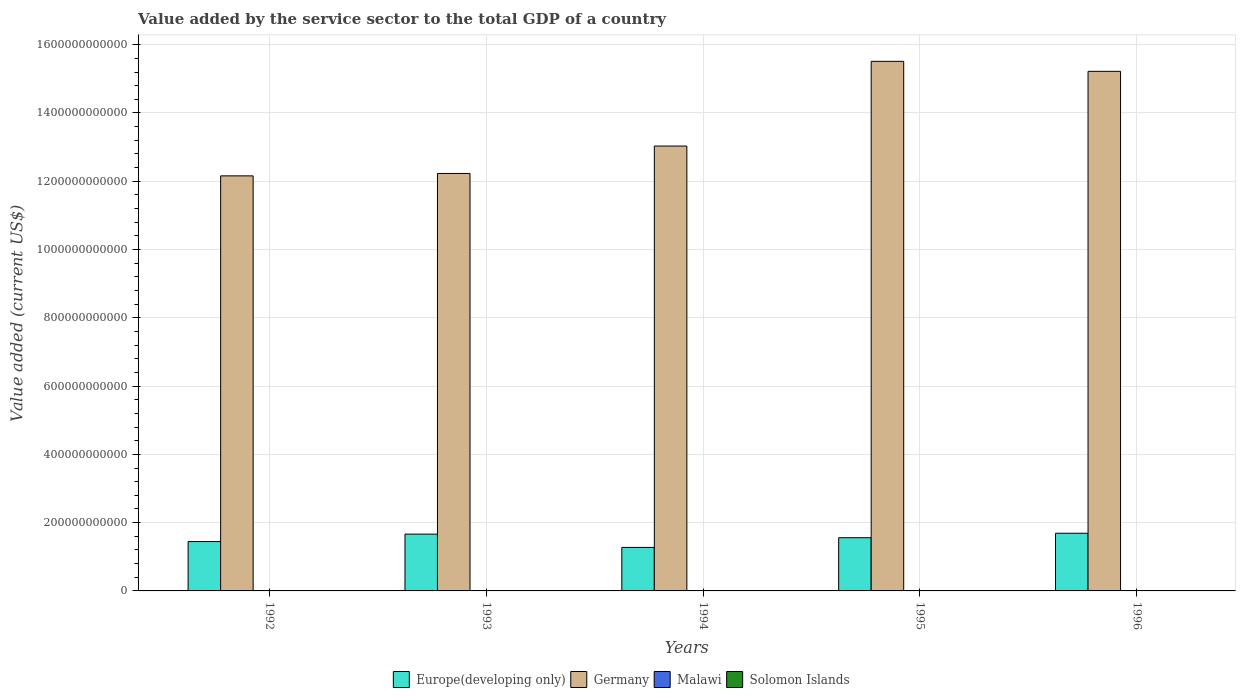How many different coloured bars are there?
Make the answer very short. 4. How many groups of bars are there?
Provide a short and direct response. 5. How many bars are there on the 4th tick from the left?
Provide a short and direct response. 4. What is the value added by the service sector to the total GDP in Germany in 1995?
Keep it short and to the point. 1.55e+12. Across all years, what is the maximum value added by the service sector to the total GDP in Malawi?
Your answer should be very brief. 9.50e+08. Across all years, what is the minimum value added by the service sector to the total GDP in Germany?
Offer a very short reply. 1.22e+12. What is the total value added by the service sector to the total GDP in Germany in the graph?
Your answer should be very brief. 6.81e+12. What is the difference between the value added by the service sector to the total GDP in Malawi in 1992 and that in 1995?
Give a very brief answer. -1.37e+08. What is the difference between the value added by the service sector to the total GDP in Germany in 1992 and the value added by the service sector to the total GDP in Malawi in 1994?
Offer a very short reply. 1.22e+12. What is the average value added by the service sector to the total GDP in Europe(developing only) per year?
Provide a succinct answer. 1.53e+11. In the year 1995, what is the difference between the value added by the service sector to the total GDP in Solomon Islands and value added by the service sector to the total GDP in Malawi?
Offer a very short reply. -4.15e+08. What is the ratio of the value added by the service sector to the total GDP in Germany in 1992 to that in 1995?
Your answer should be compact. 0.78. Is the value added by the service sector to the total GDP in Europe(developing only) in 1992 less than that in 1993?
Make the answer very short. Yes. What is the difference between the highest and the second highest value added by the service sector to the total GDP in Malawi?
Make the answer very short. 3.33e+08. What is the difference between the highest and the lowest value added by the service sector to the total GDP in Solomon Islands?
Ensure brevity in your answer.  9.79e+07. Is the sum of the value added by the service sector to the total GDP in Malawi in 1994 and 1996 greater than the maximum value added by the service sector to the total GDP in Solomon Islands across all years?
Your answer should be compact. Yes. Is it the case that in every year, the sum of the value added by the service sector to the total GDP in Solomon Islands and value added by the service sector to the total GDP in Malawi is greater than the sum of value added by the service sector to the total GDP in Germany and value added by the service sector to the total GDP in Europe(developing only)?
Make the answer very short. No. What does the 2nd bar from the left in 1996 represents?
Offer a very short reply. Germany. What does the 2nd bar from the right in 1996 represents?
Provide a short and direct response. Malawi. Is it the case that in every year, the sum of the value added by the service sector to the total GDP in Solomon Islands and value added by the service sector to the total GDP in Germany is greater than the value added by the service sector to the total GDP in Europe(developing only)?
Give a very brief answer. Yes. Are all the bars in the graph horizontal?
Your answer should be very brief. No. What is the difference between two consecutive major ticks on the Y-axis?
Keep it short and to the point. 2.00e+11. Does the graph contain grids?
Give a very brief answer. Yes. Where does the legend appear in the graph?
Your answer should be very brief. Bottom center. How are the legend labels stacked?
Make the answer very short. Horizontal. What is the title of the graph?
Give a very brief answer. Value added by the service sector to the total GDP of a country. What is the label or title of the X-axis?
Make the answer very short. Years. What is the label or title of the Y-axis?
Your answer should be compact. Value added (current US$). What is the Value added (current US$) of Europe(developing only) in 1992?
Provide a short and direct response. 1.45e+11. What is the Value added (current US$) of Germany in 1992?
Make the answer very short. 1.22e+12. What is the Value added (current US$) of Malawi in 1992?
Offer a very short reply. 4.80e+08. What is the Value added (current US$) in Solomon Islands in 1992?
Ensure brevity in your answer.  1.33e+08. What is the Value added (current US$) in Europe(developing only) in 1993?
Offer a very short reply. 1.66e+11. What is the Value added (current US$) of Germany in 1993?
Offer a terse response. 1.22e+12. What is the Value added (current US$) of Malawi in 1993?
Your response must be concise. 5.12e+08. What is the Value added (current US$) in Solomon Islands in 1993?
Keep it short and to the point. 1.49e+08. What is the Value added (current US$) in Europe(developing only) in 1994?
Ensure brevity in your answer.  1.27e+11. What is the Value added (current US$) of Germany in 1994?
Make the answer very short. 1.30e+12. What is the Value added (current US$) of Malawi in 1994?
Make the answer very short. 5.60e+08. What is the Value added (current US$) of Solomon Islands in 1994?
Give a very brief answer. 1.65e+08. What is the Value added (current US$) of Europe(developing only) in 1995?
Give a very brief answer. 1.56e+11. What is the Value added (current US$) of Germany in 1995?
Make the answer very short. 1.55e+12. What is the Value added (current US$) of Malawi in 1995?
Offer a very short reply. 6.17e+08. What is the Value added (current US$) of Solomon Islands in 1995?
Give a very brief answer. 2.01e+08. What is the Value added (current US$) in Europe(developing only) in 1996?
Offer a terse response. 1.69e+11. What is the Value added (current US$) in Germany in 1996?
Provide a succinct answer. 1.52e+12. What is the Value added (current US$) of Malawi in 1996?
Provide a succinct answer. 9.50e+08. What is the Value added (current US$) of Solomon Islands in 1996?
Your answer should be compact. 2.31e+08. Across all years, what is the maximum Value added (current US$) in Europe(developing only)?
Ensure brevity in your answer.  1.69e+11. Across all years, what is the maximum Value added (current US$) of Germany?
Your answer should be very brief. 1.55e+12. Across all years, what is the maximum Value added (current US$) of Malawi?
Give a very brief answer. 9.50e+08. Across all years, what is the maximum Value added (current US$) of Solomon Islands?
Your answer should be very brief. 2.31e+08. Across all years, what is the minimum Value added (current US$) in Europe(developing only)?
Provide a short and direct response. 1.27e+11. Across all years, what is the minimum Value added (current US$) in Germany?
Your answer should be compact. 1.22e+12. Across all years, what is the minimum Value added (current US$) of Malawi?
Offer a terse response. 4.80e+08. Across all years, what is the minimum Value added (current US$) of Solomon Islands?
Ensure brevity in your answer.  1.33e+08. What is the total Value added (current US$) of Europe(developing only) in the graph?
Offer a terse response. 7.63e+11. What is the total Value added (current US$) of Germany in the graph?
Your answer should be very brief. 6.81e+12. What is the total Value added (current US$) in Malawi in the graph?
Your answer should be very brief. 3.12e+09. What is the total Value added (current US$) in Solomon Islands in the graph?
Provide a succinct answer. 8.80e+08. What is the difference between the Value added (current US$) of Europe(developing only) in 1992 and that in 1993?
Your answer should be compact. -2.18e+1. What is the difference between the Value added (current US$) of Germany in 1992 and that in 1993?
Offer a terse response. -7.06e+09. What is the difference between the Value added (current US$) of Malawi in 1992 and that in 1993?
Make the answer very short. -3.14e+07. What is the difference between the Value added (current US$) of Solomon Islands in 1992 and that in 1993?
Keep it short and to the point. -1.59e+07. What is the difference between the Value added (current US$) of Europe(developing only) in 1992 and that in 1994?
Offer a terse response. 1.72e+1. What is the difference between the Value added (current US$) of Germany in 1992 and that in 1994?
Make the answer very short. -8.74e+1. What is the difference between the Value added (current US$) in Malawi in 1992 and that in 1994?
Provide a short and direct response. -8.02e+07. What is the difference between the Value added (current US$) of Solomon Islands in 1992 and that in 1994?
Make the answer very short. -3.12e+07. What is the difference between the Value added (current US$) in Europe(developing only) in 1992 and that in 1995?
Offer a very short reply. -1.13e+1. What is the difference between the Value added (current US$) of Germany in 1992 and that in 1995?
Make the answer very short. -3.35e+11. What is the difference between the Value added (current US$) in Malawi in 1992 and that in 1995?
Offer a very short reply. -1.37e+08. What is the difference between the Value added (current US$) in Solomon Islands in 1992 and that in 1995?
Your answer should be compact. -6.80e+07. What is the difference between the Value added (current US$) in Europe(developing only) in 1992 and that in 1996?
Your answer should be very brief. -2.44e+1. What is the difference between the Value added (current US$) of Germany in 1992 and that in 1996?
Ensure brevity in your answer.  -3.06e+11. What is the difference between the Value added (current US$) of Malawi in 1992 and that in 1996?
Provide a succinct answer. -4.69e+08. What is the difference between the Value added (current US$) of Solomon Islands in 1992 and that in 1996?
Make the answer very short. -9.79e+07. What is the difference between the Value added (current US$) of Europe(developing only) in 1993 and that in 1994?
Give a very brief answer. 3.90e+1. What is the difference between the Value added (current US$) in Germany in 1993 and that in 1994?
Offer a terse response. -8.03e+1. What is the difference between the Value added (current US$) of Malawi in 1993 and that in 1994?
Your answer should be compact. -4.88e+07. What is the difference between the Value added (current US$) in Solomon Islands in 1993 and that in 1994?
Give a very brief answer. -1.53e+07. What is the difference between the Value added (current US$) of Europe(developing only) in 1993 and that in 1995?
Provide a short and direct response. 1.05e+1. What is the difference between the Value added (current US$) of Germany in 1993 and that in 1995?
Make the answer very short. -3.28e+11. What is the difference between the Value added (current US$) in Malawi in 1993 and that in 1995?
Your answer should be compact. -1.05e+08. What is the difference between the Value added (current US$) of Solomon Islands in 1993 and that in 1995?
Make the answer very short. -5.21e+07. What is the difference between the Value added (current US$) of Europe(developing only) in 1993 and that in 1996?
Ensure brevity in your answer.  -2.57e+09. What is the difference between the Value added (current US$) in Germany in 1993 and that in 1996?
Provide a succinct answer. -2.99e+11. What is the difference between the Value added (current US$) of Malawi in 1993 and that in 1996?
Make the answer very short. -4.38e+08. What is the difference between the Value added (current US$) of Solomon Islands in 1993 and that in 1996?
Your response must be concise. -8.20e+07. What is the difference between the Value added (current US$) in Europe(developing only) in 1994 and that in 1995?
Give a very brief answer. -2.84e+1. What is the difference between the Value added (current US$) of Germany in 1994 and that in 1995?
Provide a succinct answer. -2.48e+11. What is the difference between the Value added (current US$) of Malawi in 1994 and that in 1995?
Your answer should be very brief. -5.64e+07. What is the difference between the Value added (current US$) of Solomon Islands in 1994 and that in 1995?
Your response must be concise. -3.68e+07. What is the difference between the Value added (current US$) in Europe(developing only) in 1994 and that in 1996?
Offer a very short reply. -4.15e+1. What is the difference between the Value added (current US$) of Germany in 1994 and that in 1996?
Make the answer very short. -2.19e+11. What is the difference between the Value added (current US$) in Malawi in 1994 and that in 1996?
Ensure brevity in your answer.  -3.89e+08. What is the difference between the Value added (current US$) in Solomon Islands in 1994 and that in 1996?
Make the answer very short. -6.67e+07. What is the difference between the Value added (current US$) in Europe(developing only) in 1995 and that in 1996?
Offer a very short reply. -1.31e+1. What is the difference between the Value added (current US$) in Germany in 1995 and that in 1996?
Give a very brief answer. 2.92e+1. What is the difference between the Value added (current US$) in Malawi in 1995 and that in 1996?
Your answer should be very brief. -3.33e+08. What is the difference between the Value added (current US$) in Solomon Islands in 1995 and that in 1996?
Provide a succinct answer. -2.99e+07. What is the difference between the Value added (current US$) of Europe(developing only) in 1992 and the Value added (current US$) of Germany in 1993?
Your answer should be very brief. -1.08e+12. What is the difference between the Value added (current US$) of Europe(developing only) in 1992 and the Value added (current US$) of Malawi in 1993?
Make the answer very short. 1.44e+11. What is the difference between the Value added (current US$) of Europe(developing only) in 1992 and the Value added (current US$) of Solomon Islands in 1993?
Offer a terse response. 1.44e+11. What is the difference between the Value added (current US$) of Germany in 1992 and the Value added (current US$) of Malawi in 1993?
Give a very brief answer. 1.22e+12. What is the difference between the Value added (current US$) in Germany in 1992 and the Value added (current US$) in Solomon Islands in 1993?
Give a very brief answer. 1.22e+12. What is the difference between the Value added (current US$) in Malawi in 1992 and the Value added (current US$) in Solomon Islands in 1993?
Your response must be concise. 3.31e+08. What is the difference between the Value added (current US$) in Europe(developing only) in 1992 and the Value added (current US$) in Germany in 1994?
Your response must be concise. -1.16e+12. What is the difference between the Value added (current US$) of Europe(developing only) in 1992 and the Value added (current US$) of Malawi in 1994?
Offer a terse response. 1.44e+11. What is the difference between the Value added (current US$) of Europe(developing only) in 1992 and the Value added (current US$) of Solomon Islands in 1994?
Keep it short and to the point. 1.44e+11. What is the difference between the Value added (current US$) of Germany in 1992 and the Value added (current US$) of Malawi in 1994?
Provide a succinct answer. 1.22e+12. What is the difference between the Value added (current US$) of Germany in 1992 and the Value added (current US$) of Solomon Islands in 1994?
Your answer should be very brief. 1.22e+12. What is the difference between the Value added (current US$) of Malawi in 1992 and the Value added (current US$) of Solomon Islands in 1994?
Offer a very short reply. 3.16e+08. What is the difference between the Value added (current US$) in Europe(developing only) in 1992 and the Value added (current US$) in Germany in 1995?
Your answer should be very brief. -1.41e+12. What is the difference between the Value added (current US$) of Europe(developing only) in 1992 and the Value added (current US$) of Malawi in 1995?
Give a very brief answer. 1.44e+11. What is the difference between the Value added (current US$) in Europe(developing only) in 1992 and the Value added (current US$) in Solomon Islands in 1995?
Keep it short and to the point. 1.44e+11. What is the difference between the Value added (current US$) in Germany in 1992 and the Value added (current US$) in Malawi in 1995?
Your answer should be very brief. 1.22e+12. What is the difference between the Value added (current US$) in Germany in 1992 and the Value added (current US$) in Solomon Islands in 1995?
Your response must be concise. 1.22e+12. What is the difference between the Value added (current US$) of Malawi in 1992 and the Value added (current US$) of Solomon Islands in 1995?
Offer a terse response. 2.79e+08. What is the difference between the Value added (current US$) of Europe(developing only) in 1992 and the Value added (current US$) of Germany in 1996?
Offer a terse response. -1.38e+12. What is the difference between the Value added (current US$) of Europe(developing only) in 1992 and the Value added (current US$) of Malawi in 1996?
Your answer should be compact. 1.44e+11. What is the difference between the Value added (current US$) in Europe(developing only) in 1992 and the Value added (current US$) in Solomon Islands in 1996?
Your response must be concise. 1.44e+11. What is the difference between the Value added (current US$) in Germany in 1992 and the Value added (current US$) in Malawi in 1996?
Offer a very short reply. 1.21e+12. What is the difference between the Value added (current US$) of Germany in 1992 and the Value added (current US$) of Solomon Islands in 1996?
Provide a succinct answer. 1.22e+12. What is the difference between the Value added (current US$) of Malawi in 1992 and the Value added (current US$) of Solomon Islands in 1996?
Ensure brevity in your answer.  2.49e+08. What is the difference between the Value added (current US$) of Europe(developing only) in 1993 and the Value added (current US$) of Germany in 1994?
Your answer should be compact. -1.14e+12. What is the difference between the Value added (current US$) of Europe(developing only) in 1993 and the Value added (current US$) of Malawi in 1994?
Your response must be concise. 1.66e+11. What is the difference between the Value added (current US$) in Europe(developing only) in 1993 and the Value added (current US$) in Solomon Islands in 1994?
Keep it short and to the point. 1.66e+11. What is the difference between the Value added (current US$) in Germany in 1993 and the Value added (current US$) in Malawi in 1994?
Provide a succinct answer. 1.22e+12. What is the difference between the Value added (current US$) of Germany in 1993 and the Value added (current US$) of Solomon Islands in 1994?
Make the answer very short. 1.22e+12. What is the difference between the Value added (current US$) of Malawi in 1993 and the Value added (current US$) of Solomon Islands in 1994?
Provide a succinct answer. 3.47e+08. What is the difference between the Value added (current US$) in Europe(developing only) in 1993 and the Value added (current US$) in Germany in 1995?
Give a very brief answer. -1.38e+12. What is the difference between the Value added (current US$) in Europe(developing only) in 1993 and the Value added (current US$) in Malawi in 1995?
Provide a short and direct response. 1.66e+11. What is the difference between the Value added (current US$) of Europe(developing only) in 1993 and the Value added (current US$) of Solomon Islands in 1995?
Offer a terse response. 1.66e+11. What is the difference between the Value added (current US$) in Germany in 1993 and the Value added (current US$) in Malawi in 1995?
Your response must be concise. 1.22e+12. What is the difference between the Value added (current US$) in Germany in 1993 and the Value added (current US$) in Solomon Islands in 1995?
Provide a succinct answer. 1.22e+12. What is the difference between the Value added (current US$) in Malawi in 1993 and the Value added (current US$) in Solomon Islands in 1995?
Ensure brevity in your answer.  3.10e+08. What is the difference between the Value added (current US$) of Europe(developing only) in 1993 and the Value added (current US$) of Germany in 1996?
Ensure brevity in your answer.  -1.36e+12. What is the difference between the Value added (current US$) of Europe(developing only) in 1993 and the Value added (current US$) of Malawi in 1996?
Provide a short and direct response. 1.65e+11. What is the difference between the Value added (current US$) in Europe(developing only) in 1993 and the Value added (current US$) in Solomon Islands in 1996?
Offer a very short reply. 1.66e+11. What is the difference between the Value added (current US$) of Germany in 1993 and the Value added (current US$) of Malawi in 1996?
Ensure brevity in your answer.  1.22e+12. What is the difference between the Value added (current US$) in Germany in 1993 and the Value added (current US$) in Solomon Islands in 1996?
Provide a succinct answer. 1.22e+12. What is the difference between the Value added (current US$) of Malawi in 1993 and the Value added (current US$) of Solomon Islands in 1996?
Provide a short and direct response. 2.80e+08. What is the difference between the Value added (current US$) in Europe(developing only) in 1994 and the Value added (current US$) in Germany in 1995?
Keep it short and to the point. -1.42e+12. What is the difference between the Value added (current US$) in Europe(developing only) in 1994 and the Value added (current US$) in Malawi in 1995?
Your response must be concise. 1.27e+11. What is the difference between the Value added (current US$) in Europe(developing only) in 1994 and the Value added (current US$) in Solomon Islands in 1995?
Provide a short and direct response. 1.27e+11. What is the difference between the Value added (current US$) of Germany in 1994 and the Value added (current US$) of Malawi in 1995?
Provide a succinct answer. 1.30e+12. What is the difference between the Value added (current US$) in Germany in 1994 and the Value added (current US$) in Solomon Islands in 1995?
Ensure brevity in your answer.  1.30e+12. What is the difference between the Value added (current US$) in Malawi in 1994 and the Value added (current US$) in Solomon Islands in 1995?
Your response must be concise. 3.59e+08. What is the difference between the Value added (current US$) in Europe(developing only) in 1994 and the Value added (current US$) in Germany in 1996?
Give a very brief answer. -1.39e+12. What is the difference between the Value added (current US$) in Europe(developing only) in 1994 and the Value added (current US$) in Malawi in 1996?
Your response must be concise. 1.27e+11. What is the difference between the Value added (current US$) of Europe(developing only) in 1994 and the Value added (current US$) of Solomon Islands in 1996?
Your answer should be very brief. 1.27e+11. What is the difference between the Value added (current US$) in Germany in 1994 and the Value added (current US$) in Malawi in 1996?
Give a very brief answer. 1.30e+12. What is the difference between the Value added (current US$) of Germany in 1994 and the Value added (current US$) of Solomon Islands in 1996?
Provide a short and direct response. 1.30e+12. What is the difference between the Value added (current US$) in Malawi in 1994 and the Value added (current US$) in Solomon Islands in 1996?
Your answer should be very brief. 3.29e+08. What is the difference between the Value added (current US$) of Europe(developing only) in 1995 and the Value added (current US$) of Germany in 1996?
Your answer should be compact. -1.37e+12. What is the difference between the Value added (current US$) in Europe(developing only) in 1995 and the Value added (current US$) in Malawi in 1996?
Ensure brevity in your answer.  1.55e+11. What is the difference between the Value added (current US$) in Europe(developing only) in 1995 and the Value added (current US$) in Solomon Islands in 1996?
Provide a short and direct response. 1.56e+11. What is the difference between the Value added (current US$) of Germany in 1995 and the Value added (current US$) of Malawi in 1996?
Your answer should be compact. 1.55e+12. What is the difference between the Value added (current US$) of Germany in 1995 and the Value added (current US$) of Solomon Islands in 1996?
Ensure brevity in your answer.  1.55e+12. What is the difference between the Value added (current US$) of Malawi in 1995 and the Value added (current US$) of Solomon Islands in 1996?
Provide a short and direct response. 3.86e+08. What is the average Value added (current US$) of Europe(developing only) per year?
Provide a succinct answer. 1.53e+11. What is the average Value added (current US$) in Germany per year?
Your response must be concise. 1.36e+12. What is the average Value added (current US$) of Malawi per year?
Keep it short and to the point. 6.24e+08. What is the average Value added (current US$) of Solomon Islands per year?
Provide a short and direct response. 1.76e+08. In the year 1992, what is the difference between the Value added (current US$) of Europe(developing only) and Value added (current US$) of Germany?
Your answer should be compact. -1.07e+12. In the year 1992, what is the difference between the Value added (current US$) in Europe(developing only) and Value added (current US$) in Malawi?
Your response must be concise. 1.44e+11. In the year 1992, what is the difference between the Value added (current US$) of Europe(developing only) and Value added (current US$) of Solomon Islands?
Provide a succinct answer. 1.44e+11. In the year 1992, what is the difference between the Value added (current US$) in Germany and Value added (current US$) in Malawi?
Keep it short and to the point. 1.22e+12. In the year 1992, what is the difference between the Value added (current US$) in Germany and Value added (current US$) in Solomon Islands?
Provide a succinct answer. 1.22e+12. In the year 1992, what is the difference between the Value added (current US$) of Malawi and Value added (current US$) of Solomon Islands?
Keep it short and to the point. 3.47e+08. In the year 1993, what is the difference between the Value added (current US$) in Europe(developing only) and Value added (current US$) in Germany?
Your answer should be very brief. -1.06e+12. In the year 1993, what is the difference between the Value added (current US$) of Europe(developing only) and Value added (current US$) of Malawi?
Offer a terse response. 1.66e+11. In the year 1993, what is the difference between the Value added (current US$) of Europe(developing only) and Value added (current US$) of Solomon Islands?
Your response must be concise. 1.66e+11. In the year 1993, what is the difference between the Value added (current US$) in Germany and Value added (current US$) in Malawi?
Ensure brevity in your answer.  1.22e+12. In the year 1993, what is the difference between the Value added (current US$) of Germany and Value added (current US$) of Solomon Islands?
Provide a succinct answer. 1.22e+12. In the year 1993, what is the difference between the Value added (current US$) in Malawi and Value added (current US$) in Solomon Islands?
Provide a short and direct response. 3.62e+08. In the year 1994, what is the difference between the Value added (current US$) in Europe(developing only) and Value added (current US$) in Germany?
Provide a succinct answer. -1.18e+12. In the year 1994, what is the difference between the Value added (current US$) in Europe(developing only) and Value added (current US$) in Malawi?
Ensure brevity in your answer.  1.27e+11. In the year 1994, what is the difference between the Value added (current US$) of Europe(developing only) and Value added (current US$) of Solomon Islands?
Make the answer very short. 1.27e+11. In the year 1994, what is the difference between the Value added (current US$) in Germany and Value added (current US$) in Malawi?
Make the answer very short. 1.30e+12. In the year 1994, what is the difference between the Value added (current US$) in Germany and Value added (current US$) in Solomon Islands?
Give a very brief answer. 1.30e+12. In the year 1994, what is the difference between the Value added (current US$) of Malawi and Value added (current US$) of Solomon Islands?
Offer a terse response. 3.96e+08. In the year 1995, what is the difference between the Value added (current US$) of Europe(developing only) and Value added (current US$) of Germany?
Offer a terse response. -1.40e+12. In the year 1995, what is the difference between the Value added (current US$) of Europe(developing only) and Value added (current US$) of Malawi?
Your answer should be very brief. 1.55e+11. In the year 1995, what is the difference between the Value added (current US$) of Europe(developing only) and Value added (current US$) of Solomon Islands?
Give a very brief answer. 1.56e+11. In the year 1995, what is the difference between the Value added (current US$) of Germany and Value added (current US$) of Malawi?
Provide a succinct answer. 1.55e+12. In the year 1995, what is the difference between the Value added (current US$) in Germany and Value added (current US$) in Solomon Islands?
Ensure brevity in your answer.  1.55e+12. In the year 1995, what is the difference between the Value added (current US$) in Malawi and Value added (current US$) in Solomon Islands?
Offer a terse response. 4.15e+08. In the year 1996, what is the difference between the Value added (current US$) of Europe(developing only) and Value added (current US$) of Germany?
Ensure brevity in your answer.  -1.35e+12. In the year 1996, what is the difference between the Value added (current US$) in Europe(developing only) and Value added (current US$) in Malawi?
Your response must be concise. 1.68e+11. In the year 1996, what is the difference between the Value added (current US$) in Europe(developing only) and Value added (current US$) in Solomon Islands?
Your answer should be very brief. 1.69e+11. In the year 1996, what is the difference between the Value added (current US$) of Germany and Value added (current US$) of Malawi?
Give a very brief answer. 1.52e+12. In the year 1996, what is the difference between the Value added (current US$) of Germany and Value added (current US$) of Solomon Islands?
Provide a short and direct response. 1.52e+12. In the year 1996, what is the difference between the Value added (current US$) of Malawi and Value added (current US$) of Solomon Islands?
Offer a very short reply. 7.18e+08. What is the ratio of the Value added (current US$) in Europe(developing only) in 1992 to that in 1993?
Provide a short and direct response. 0.87. What is the ratio of the Value added (current US$) in Germany in 1992 to that in 1993?
Make the answer very short. 0.99. What is the ratio of the Value added (current US$) of Malawi in 1992 to that in 1993?
Provide a short and direct response. 0.94. What is the ratio of the Value added (current US$) in Solomon Islands in 1992 to that in 1993?
Provide a succinct answer. 0.89. What is the ratio of the Value added (current US$) of Europe(developing only) in 1992 to that in 1994?
Ensure brevity in your answer.  1.13. What is the ratio of the Value added (current US$) in Germany in 1992 to that in 1994?
Your answer should be compact. 0.93. What is the ratio of the Value added (current US$) in Malawi in 1992 to that in 1994?
Your response must be concise. 0.86. What is the ratio of the Value added (current US$) in Solomon Islands in 1992 to that in 1994?
Your answer should be very brief. 0.81. What is the ratio of the Value added (current US$) in Europe(developing only) in 1992 to that in 1995?
Your answer should be very brief. 0.93. What is the ratio of the Value added (current US$) in Germany in 1992 to that in 1995?
Provide a short and direct response. 0.78. What is the ratio of the Value added (current US$) of Malawi in 1992 to that in 1995?
Your answer should be very brief. 0.78. What is the ratio of the Value added (current US$) in Solomon Islands in 1992 to that in 1995?
Ensure brevity in your answer.  0.66. What is the ratio of the Value added (current US$) in Europe(developing only) in 1992 to that in 1996?
Your answer should be compact. 0.86. What is the ratio of the Value added (current US$) of Germany in 1992 to that in 1996?
Offer a very short reply. 0.8. What is the ratio of the Value added (current US$) of Malawi in 1992 to that in 1996?
Your answer should be very brief. 0.51. What is the ratio of the Value added (current US$) of Solomon Islands in 1992 to that in 1996?
Provide a short and direct response. 0.58. What is the ratio of the Value added (current US$) in Europe(developing only) in 1993 to that in 1994?
Give a very brief answer. 1.31. What is the ratio of the Value added (current US$) of Germany in 1993 to that in 1994?
Offer a very short reply. 0.94. What is the ratio of the Value added (current US$) in Malawi in 1993 to that in 1994?
Keep it short and to the point. 0.91. What is the ratio of the Value added (current US$) of Solomon Islands in 1993 to that in 1994?
Make the answer very short. 0.91. What is the ratio of the Value added (current US$) of Europe(developing only) in 1993 to that in 1995?
Keep it short and to the point. 1.07. What is the ratio of the Value added (current US$) in Germany in 1993 to that in 1995?
Provide a short and direct response. 0.79. What is the ratio of the Value added (current US$) of Malawi in 1993 to that in 1995?
Keep it short and to the point. 0.83. What is the ratio of the Value added (current US$) in Solomon Islands in 1993 to that in 1995?
Offer a terse response. 0.74. What is the ratio of the Value added (current US$) of Germany in 1993 to that in 1996?
Your answer should be very brief. 0.8. What is the ratio of the Value added (current US$) in Malawi in 1993 to that in 1996?
Make the answer very short. 0.54. What is the ratio of the Value added (current US$) in Solomon Islands in 1993 to that in 1996?
Make the answer very short. 0.65. What is the ratio of the Value added (current US$) of Europe(developing only) in 1994 to that in 1995?
Ensure brevity in your answer.  0.82. What is the ratio of the Value added (current US$) of Germany in 1994 to that in 1995?
Your response must be concise. 0.84. What is the ratio of the Value added (current US$) in Malawi in 1994 to that in 1995?
Your answer should be compact. 0.91. What is the ratio of the Value added (current US$) of Solomon Islands in 1994 to that in 1995?
Give a very brief answer. 0.82. What is the ratio of the Value added (current US$) of Europe(developing only) in 1994 to that in 1996?
Offer a terse response. 0.75. What is the ratio of the Value added (current US$) in Germany in 1994 to that in 1996?
Provide a short and direct response. 0.86. What is the ratio of the Value added (current US$) of Malawi in 1994 to that in 1996?
Offer a very short reply. 0.59. What is the ratio of the Value added (current US$) in Solomon Islands in 1994 to that in 1996?
Offer a terse response. 0.71. What is the ratio of the Value added (current US$) of Europe(developing only) in 1995 to that in 1996?
Offer a terse response. 0.92. What is the ratio of the Value added (current US$) in Germany in 1995 to that in 1996?
Provide a short and direct response. 1.02. What is the ratio of the Value added (current US$) of Malawi in 1995 to that in 1996?
Give a very brief answer. 0.65. What is the ratio of the Value added (current US$) in Solomon Islands in 1995 to that in 1996?
Your answer should be compact. 0.87. What is the difference between the highest and the second highest Value added (current US$) of Europe(developing only)?
Your response must be concise. 2.57e+09. What is the difference between the highest and the second highest Value added (current US$) in Germany?
Ensure brevity in your answer.  2.92e+1. What is the difference between the highest and the second highest Value added (current US$) in Malawi?
Keep it short and to the point. 3.33e+08. What is the difference between the highest and the second highest Value added (current US$) of Solomon Islands?
Your answer should be very brief. 2.99e+07. What is the difference between the highest and the lowest Value added (current US$) in Europe(developing only)?
Give a very brief answer. 4.15e+1. What is the difference between the highest and the lowest Value added (current US$) of Germany?
Your answer should be very brief. 3.35e+11. What is the difference between the highest and the lowest Value added (current US$) in Malawi?
Provide a short and direct response. 4.69e+08. What is the difference between the highest and the lowest Value added (current US$) in Solomon Islands?
Offer a very short reply. 9.79e+07. 